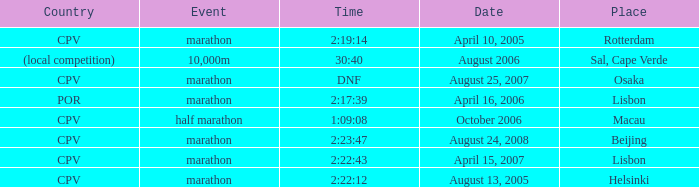What is the Place of the Event on August 25, 2007? Osaka. 